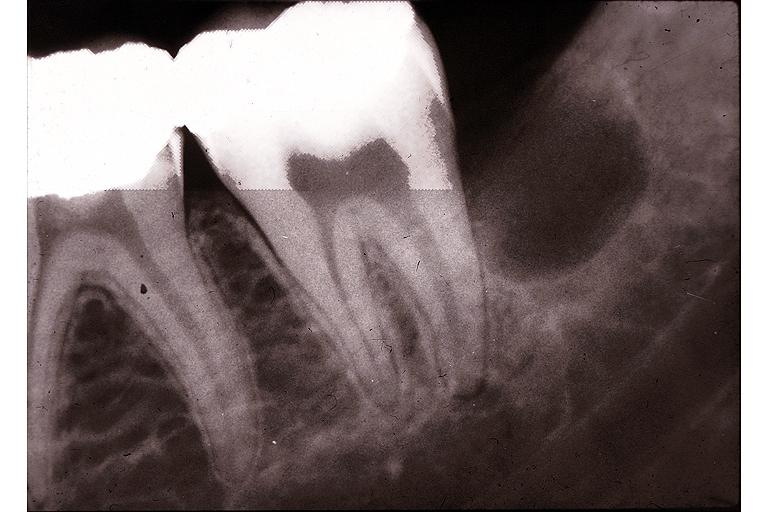where is this?
Answer the question using a single word or phrase. Oral 